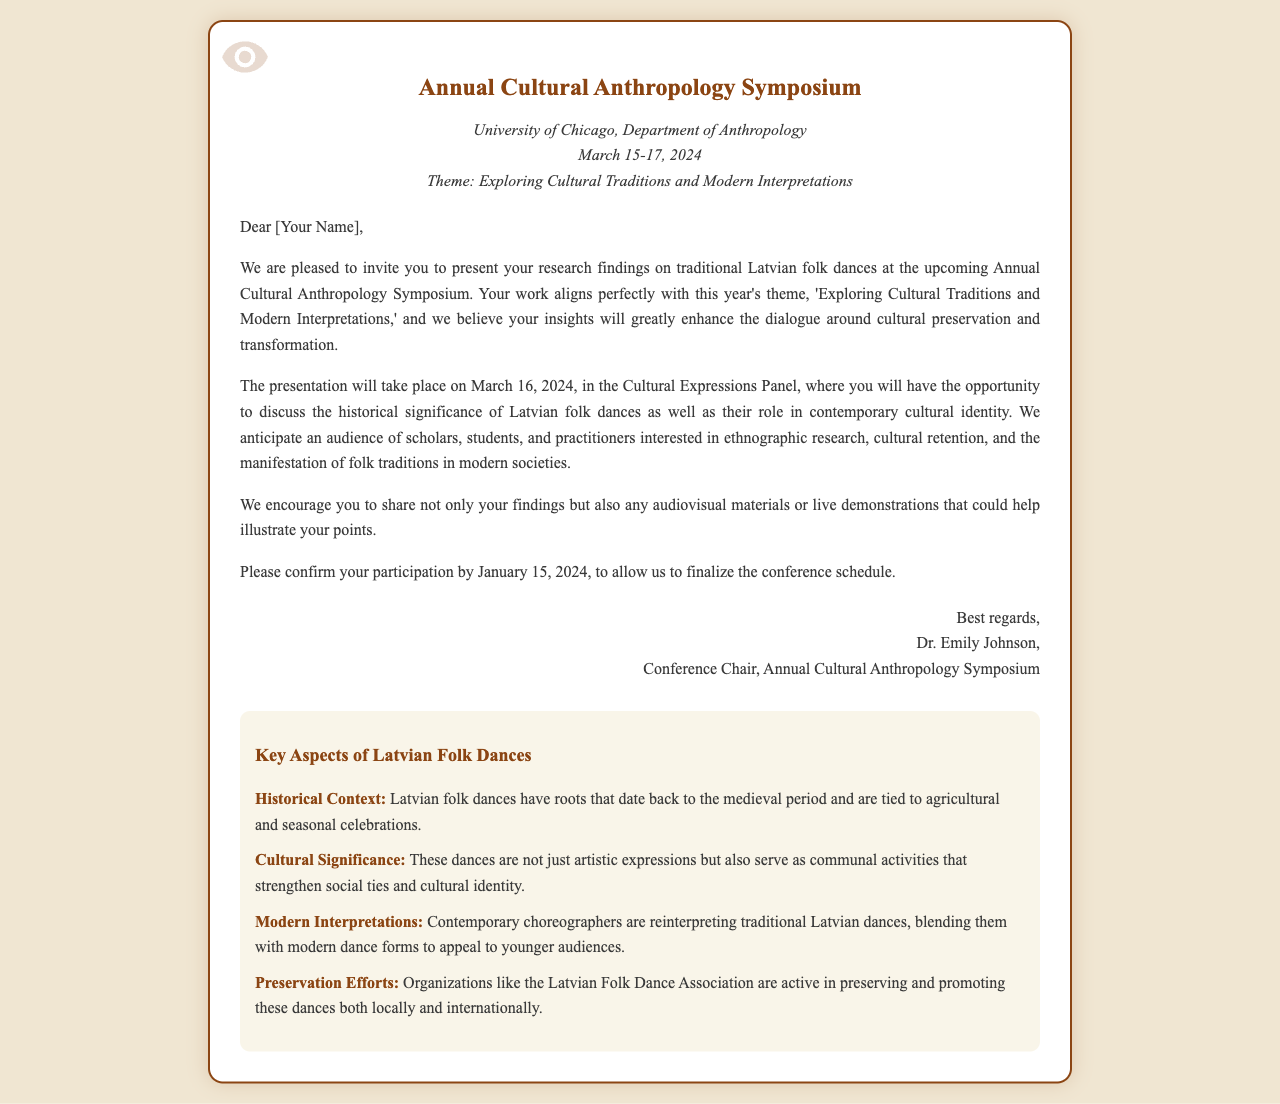What is the name of the symposium? The symposium is titled 'Annual Cultural Anthropology Symposium' as mentioned in the document.
Answer: Annual Cultural Anthropology Symposium Where will the symposium take place? The document specifies that the venue for the symposium is the University of Chicago, Department of Anthropology.
Answer: University of Chicago, Department of Anthropology When is the deadline for participation confirmation? The invitation states that confirmation of participation is required by January 15, 2024.
Answer: January 15, 2024 What is the theme of this year's symposium? The document clearly states that the theme is 'Exploring Cultural Traditions and Modern Interpretations.'
Answer: Exploring Cultural Traditions and Modern Interpretations Who is the conference chair? The document identifies Dr. Emily Johnson as the conference chair.
Answer: Dr. Emily Johnson What will be discussed in the Cultural Expressions Panel? The panel will focus on the historical significance of Latvian folk dances and their role in contemporary cultural identity.
Answer: Historical significance of Latvian folk dances and contemporary cultural identity Which date is your presentation scheduled? The document indicates that the presentation is scheduled for March 16, 2024.
Answer: March 16, 2024 What organization is mentioned regarding preservation efforts? The letter notes the involvement of the Latvian Folk Dance Association in preserving and promoting folk dances.
Answer: Latvian Folk Dance Association What kind of materials are encouraged to be shared during the presentation? The document encourages sharing audiovisual materials or live demonstrations.
Answer: Audiovisual materials or live demonstrations 